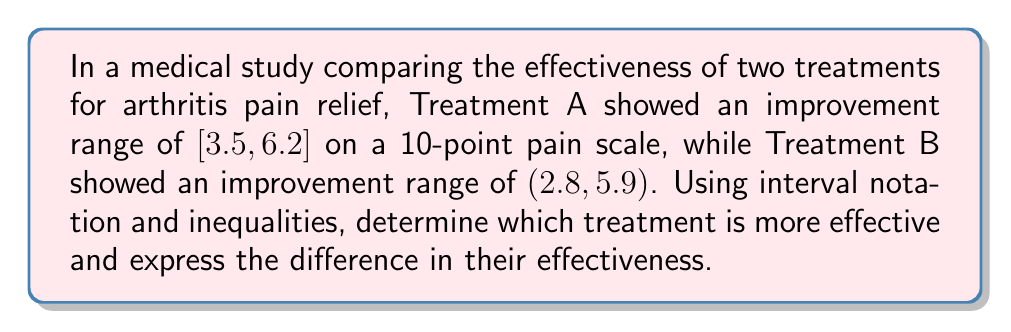Could you help me with this problem? 1. First, let's interpret the interval notations:
   Treatment A: $[3.5, 6.2]$ means $3.5 \leq x \leq 6.2$
   Treatment B: $(2.8, 5.9)$ means $2.8 < x < 5.9$

2. To compare effectiveness, we'll look at the upper and lower bounds:
   - Lower bound: Treatment A (3.5) > Treatment B (2.8)
   - Upper bound: Treatment A (6.2) > Treatment B (5.9)

3. Treatment A has higher values for both bounds, indicating it's more effective.

4. To express the difference in effectiveness, we'll subtract Treatment B's interval from Treatment A's:
   $[3.5, 6.2] - (2.8, 5.9)$

5. For interval subtraction:
   - Lower bound: $3.5 - 5.9 = -2.4$
   - Upper bound: $6.2 - 2.8 = 3.4$

6. The resulting interval is $(-2.4, 3.4)$, which represents the range of possible differences in effectiveness between the treatments.

7. We can express this as an inequality:
   $-2.4 < \text{Difference in effectiveness} < 3.4$
Answer: Treatment A is more effective; $-2.4 < \text{Difference} < 3.4$ 